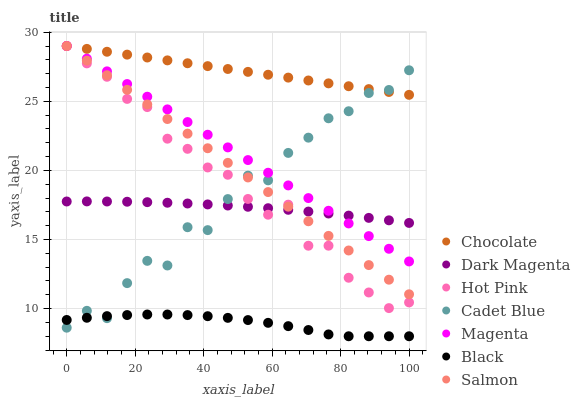Does Black have the minimum area under the curve?
Answer yes or no. Yes. Does Chocolate have the maximum area under the curve?
Answer yes or no. Yes. Does Dark Magenta have the minimum area under the curve?
Answer yes or no. No. Does Dark Magenta have the maximum area under the curve?
Answer yes or no. No. Is Chocolate the smoothest?
Answer yes or no. Yes. Is Cadet Blue the roughest?
Answer yes or no. Yes. Is Dark Magenta the smoothest?
Answer yes or no. No. Is Dark Magenta the roughest?
Answer yes or no. No. Does Black have the lowest value?
Answer yes or no. Yes. Does Dark Magenta have the lowest value?
Answer yes or no. No. Does Magenta have the highest value?
Answer yes or no. Yes. Does Dark Magenta have the highest value?
Answer yes or no. No. Is Dark Magenta less than Chocolate?
Answer yes or no. Yes. Is Hot Pink greater than Black?
Answer yes or no. Yes. Does Salmon intersect Magenta?
Answer yes or no. Yes. Is Salmon less than Magenta?
Answer yes or no. No. Is Salmon greater than Magenta?
Answer yes or no. No. Does Dark Magenta intersect Chocolate?
Answer yes or no. No. 